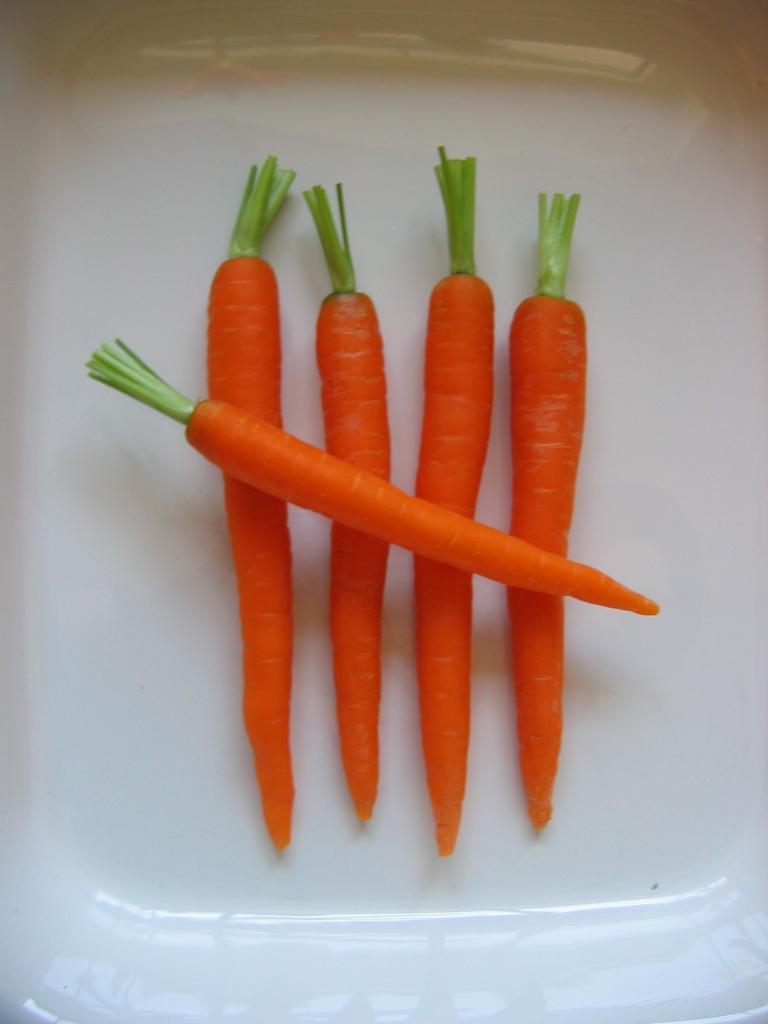Could you give a brief overview of what you see in this image? In this picture we can see a plate, there are five carrots present in the plate. 